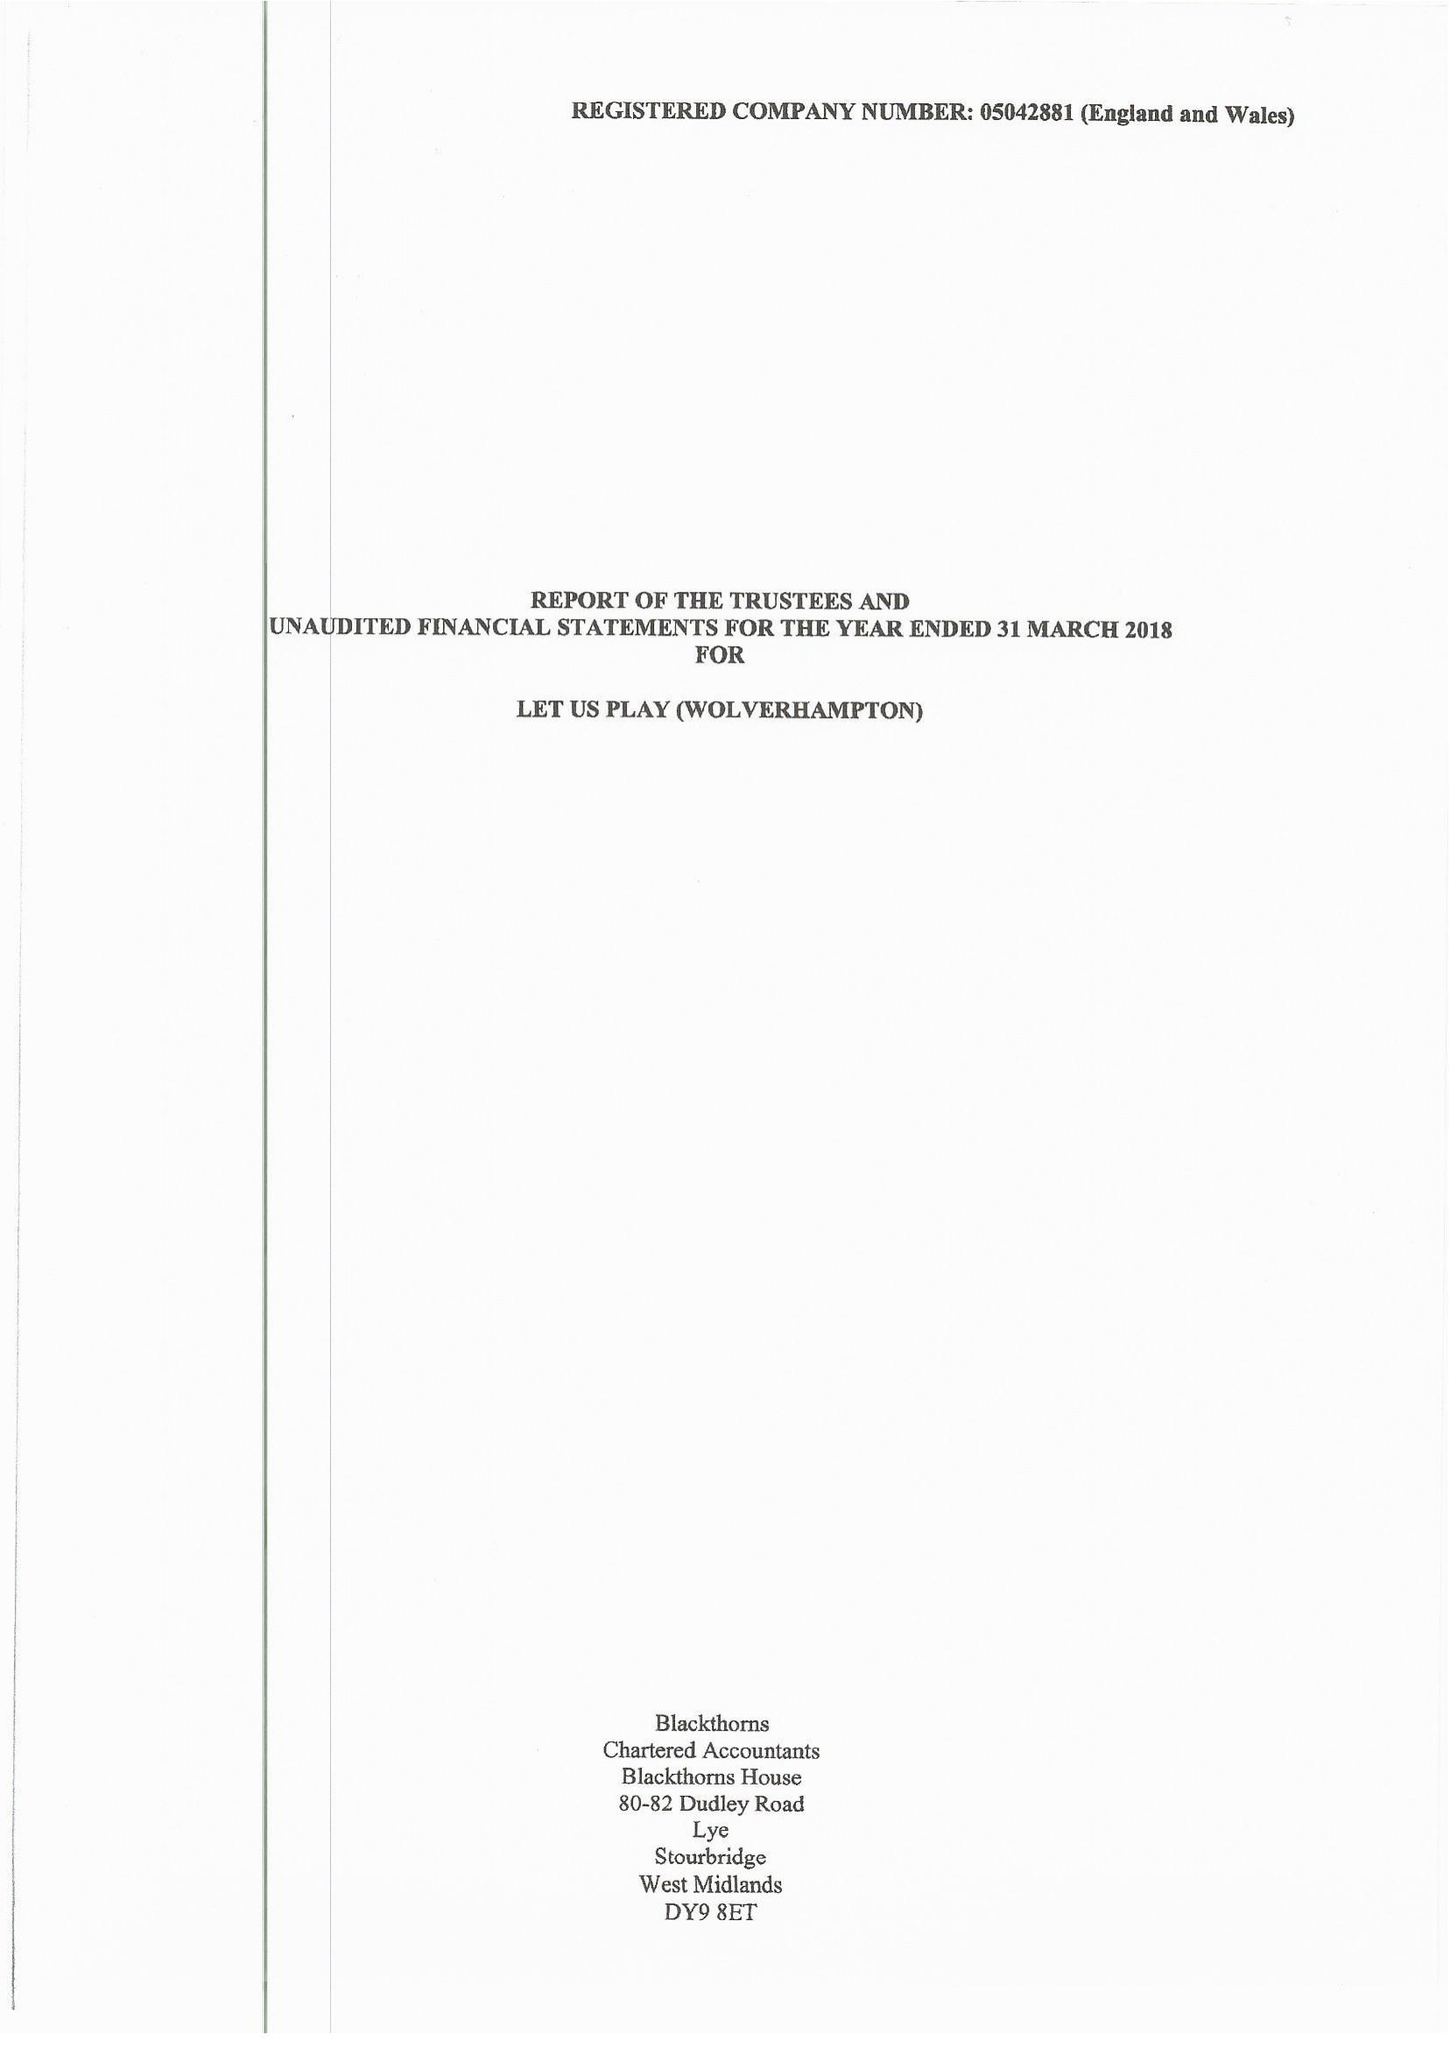What is the value for the address__postcode?
Answer the question using a single word or phrase. WV10 9LE 